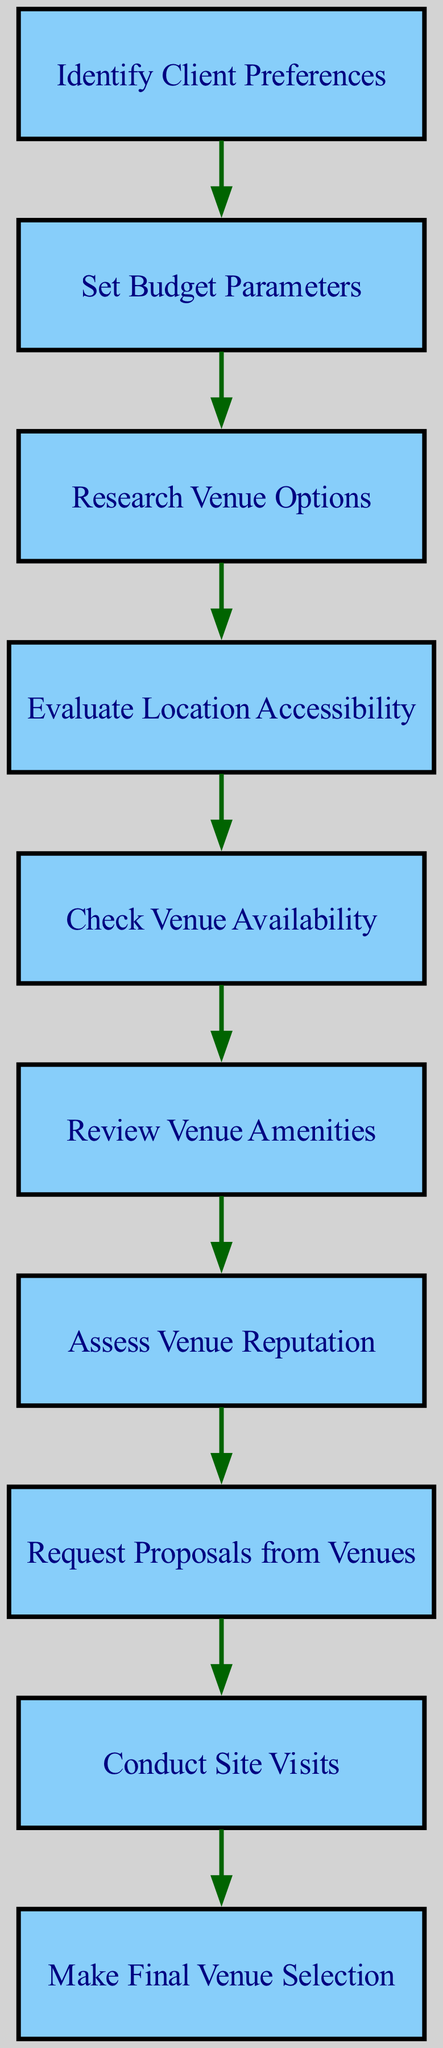What is the first step in the evaluation process? The first step in the flow chart is to "Identify Client Preferences". This is represented as the starting node in the diagram, indicating it is the initial action required before proceeding to the next steps.
Answer: Identify Client Preferences How many nodes are in the flow chart? The flow chart contains a total of 10 nodes, which represent different steps in the evaluation process. Each distinct action or decision point is marked as a separate node in the diagram.
Answer: 10 What node comes after "Check Venue Availability"? After "Check Venue Availability", the next node is "Review Venue Amenities". This flow follows the edges connecting these steps in the diagram.
Answer: Review Venue Amenities Which node evaluates the accessibility of the venue? The node that evaluates the accessibility of the venue is "Evaluate Location Accessibility". This is a distinct step focusing on how reachable the venue is for clients and guests.
Answer: Evaluate Location Accessibility What is the relationship between "Assess Venue Reputation" and "Request Proposals from Venues"? The relationship is sequential; "Assess Venue Reputation" leads directly to "Request Proposals from Venues". This indicates that proposals are requested after assessing how reputable a venue is.
Answer: Sequential relationship How many edges are there in the diagram? There are 9 edges in the diagram, which represent the connections and flow between the various steps or nodes. Each edge indicates a transition from one action to another in the evaluation process.
Answer: 9 What step follows "Conduct Site Visits"? The step that follows "Conduct Site Visits" is "Make Final Venue Selection". This indicates that after visiting potential venues, the selection process occurs.
Answer: Make Final Venue Selection Why is "Set Budget Parameters" important in the process? "Set Budget Parameters" is crucial as it establishes financial limits before researching venue options; this ensures that all subsequent evaluations align with the client's budget.
Answer: It establishes financial limits What process follows after identifying client preferences? After identifying client preferences, the next step in the process is to "Set Budget Parameters". This indicates that understanding client needs is immediately followed by determining what can be spent.
Answer: Set Budget Parameters 